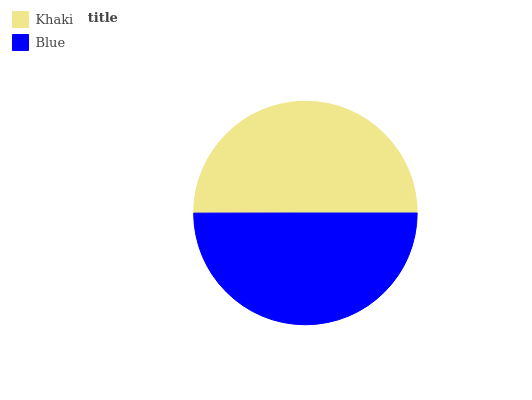Is Blue the minimum?
Answer yes or no. Yes. Is Khaki the maximum?
Answer yes or no. Yes. Is Blue the maximum?
Answer yes or no. No. Is Khaki greater than Blue?
Answer yes or no. Yes. Is Blue less than Khaki?
Answer yes or no. Yes. Is Blue greater than Khaki?
Answer yes or no. No. Is Khaki less than Blue?
Answer yes or no. No. Is Khaki the high median?
Answer yes or no. Yes. Is Blue the low median?
Answer yes or no. Yes. Is Blue the high median?
Answer yes or no. No. Is Khaki the low median?
Answer yes or no. No. 